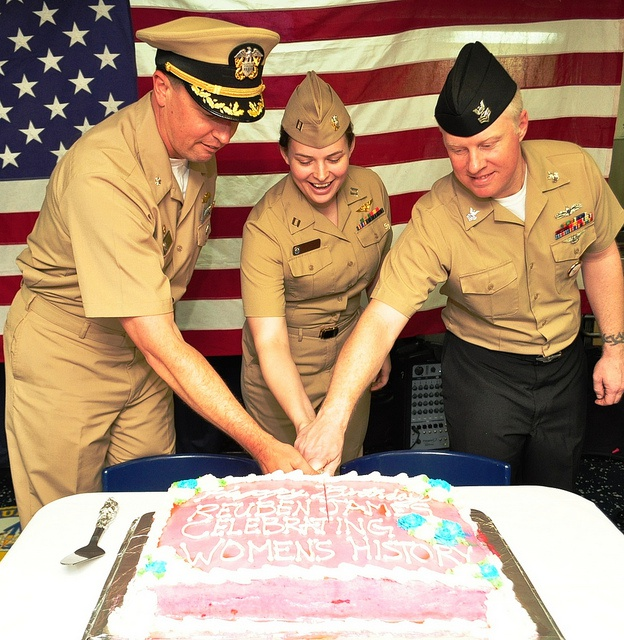Describe the objects in this image and their specific colors. I can see people in black, tan, and gray tones, people in black, tan, khaki, and gray tones, cake in black, white, lightpink, tan, and navy tones, dining table in black, white, gray, and tan tones, and chair in black, navy, gray, and darkblue tones in this image. 